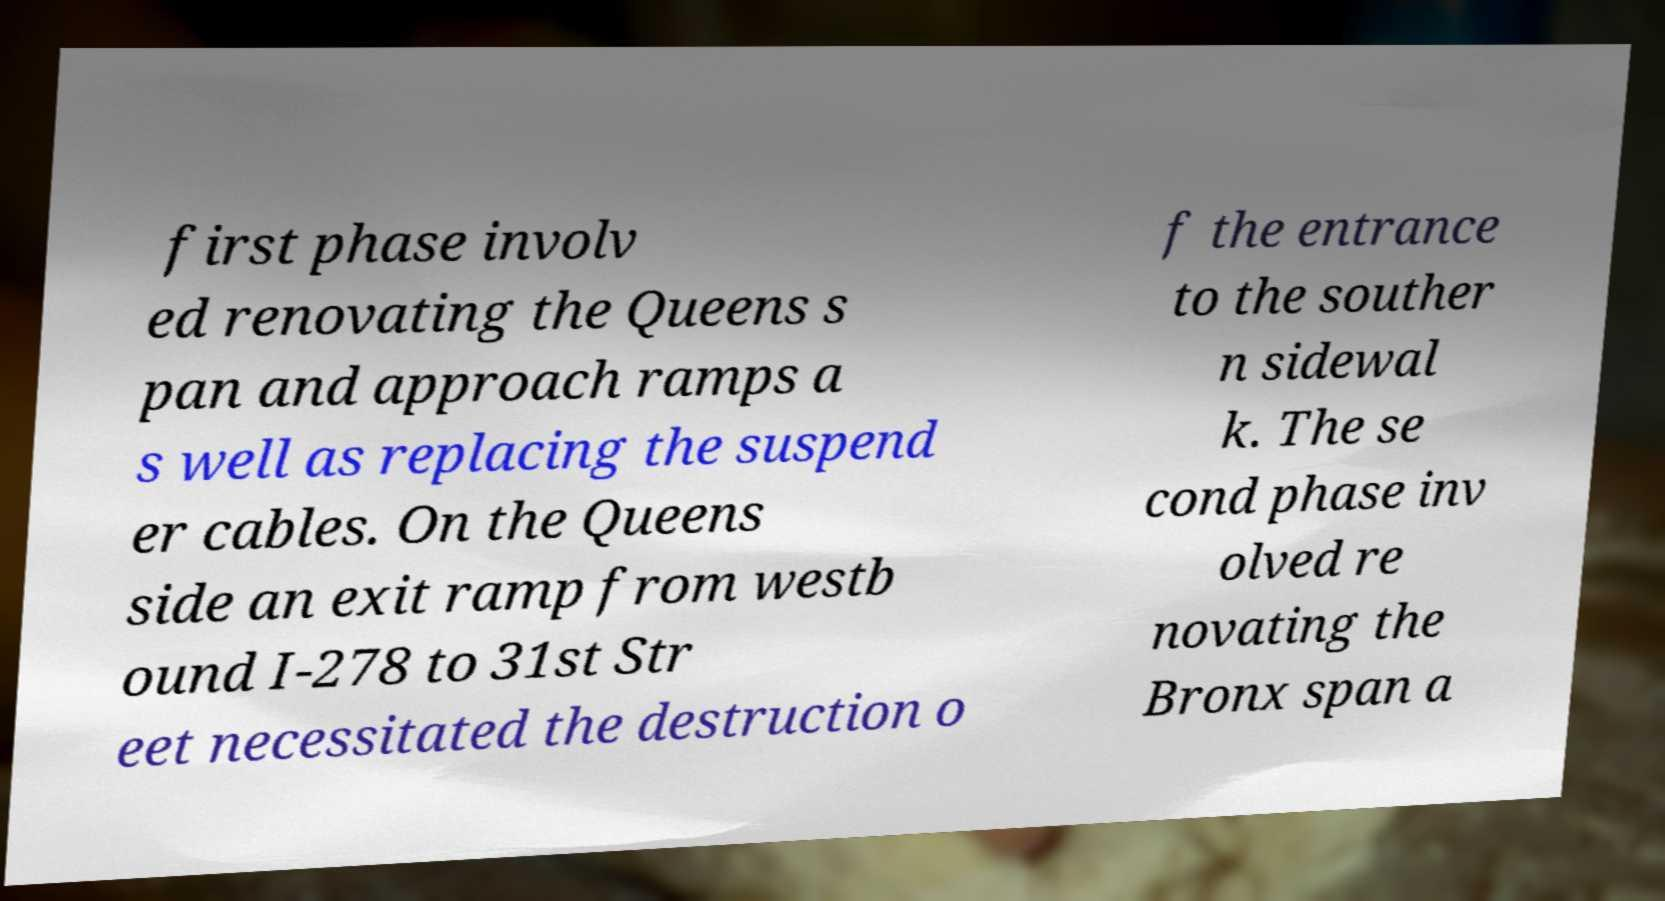I need the written content from this picture converted into text. Can you do that? first phase involv ed renovating the Queens s pan and approach ramps a s well as replacing the suspend er cables. On the Queens side an exit ramp from westb ound I-278 to 31st Str eet necessitated the destruction o f the entrance to the souther n sidewal k. The se cond phase inv olved re novating the Bronx span a 